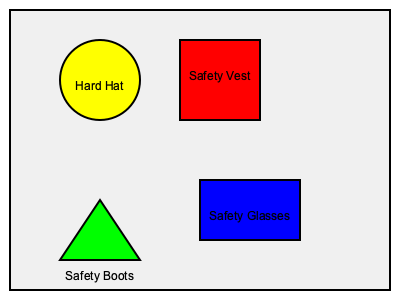Which of the personal protective equipment (PPE) items shown in the image is most crucial for protecting against falling objects on a construction site? To answer this question, we need to consider the primary function of each PPE item shown in the image and their relevance to protection against falling objects:

1. Hard Hat (yellow circle): Designed specifically to protect the head from falling objects and overhead hazards. It's made of a rigid material that can absorb and distribute the force of impact.

2. Safety Vest (red rectangle): Primarily used for visibility and doesn't offer protection against falling objects.

3. Safety Boots (green triangle): Protect feet from heavy objects falling directly on them, but not designed for overhead protection.

4. Safety Glasses (blue rectangle): Protect eyes from small particles and debris, but not designed for protection against larger falling objects.

Among these options, the hard hat is the most crucial for protecting against falling objects on a construction site. It's specifically designed to protect the most vulnerable and vital part of the body - the head - from overhead hazards, which are common in construction environments.
Answer: Hard Hat 